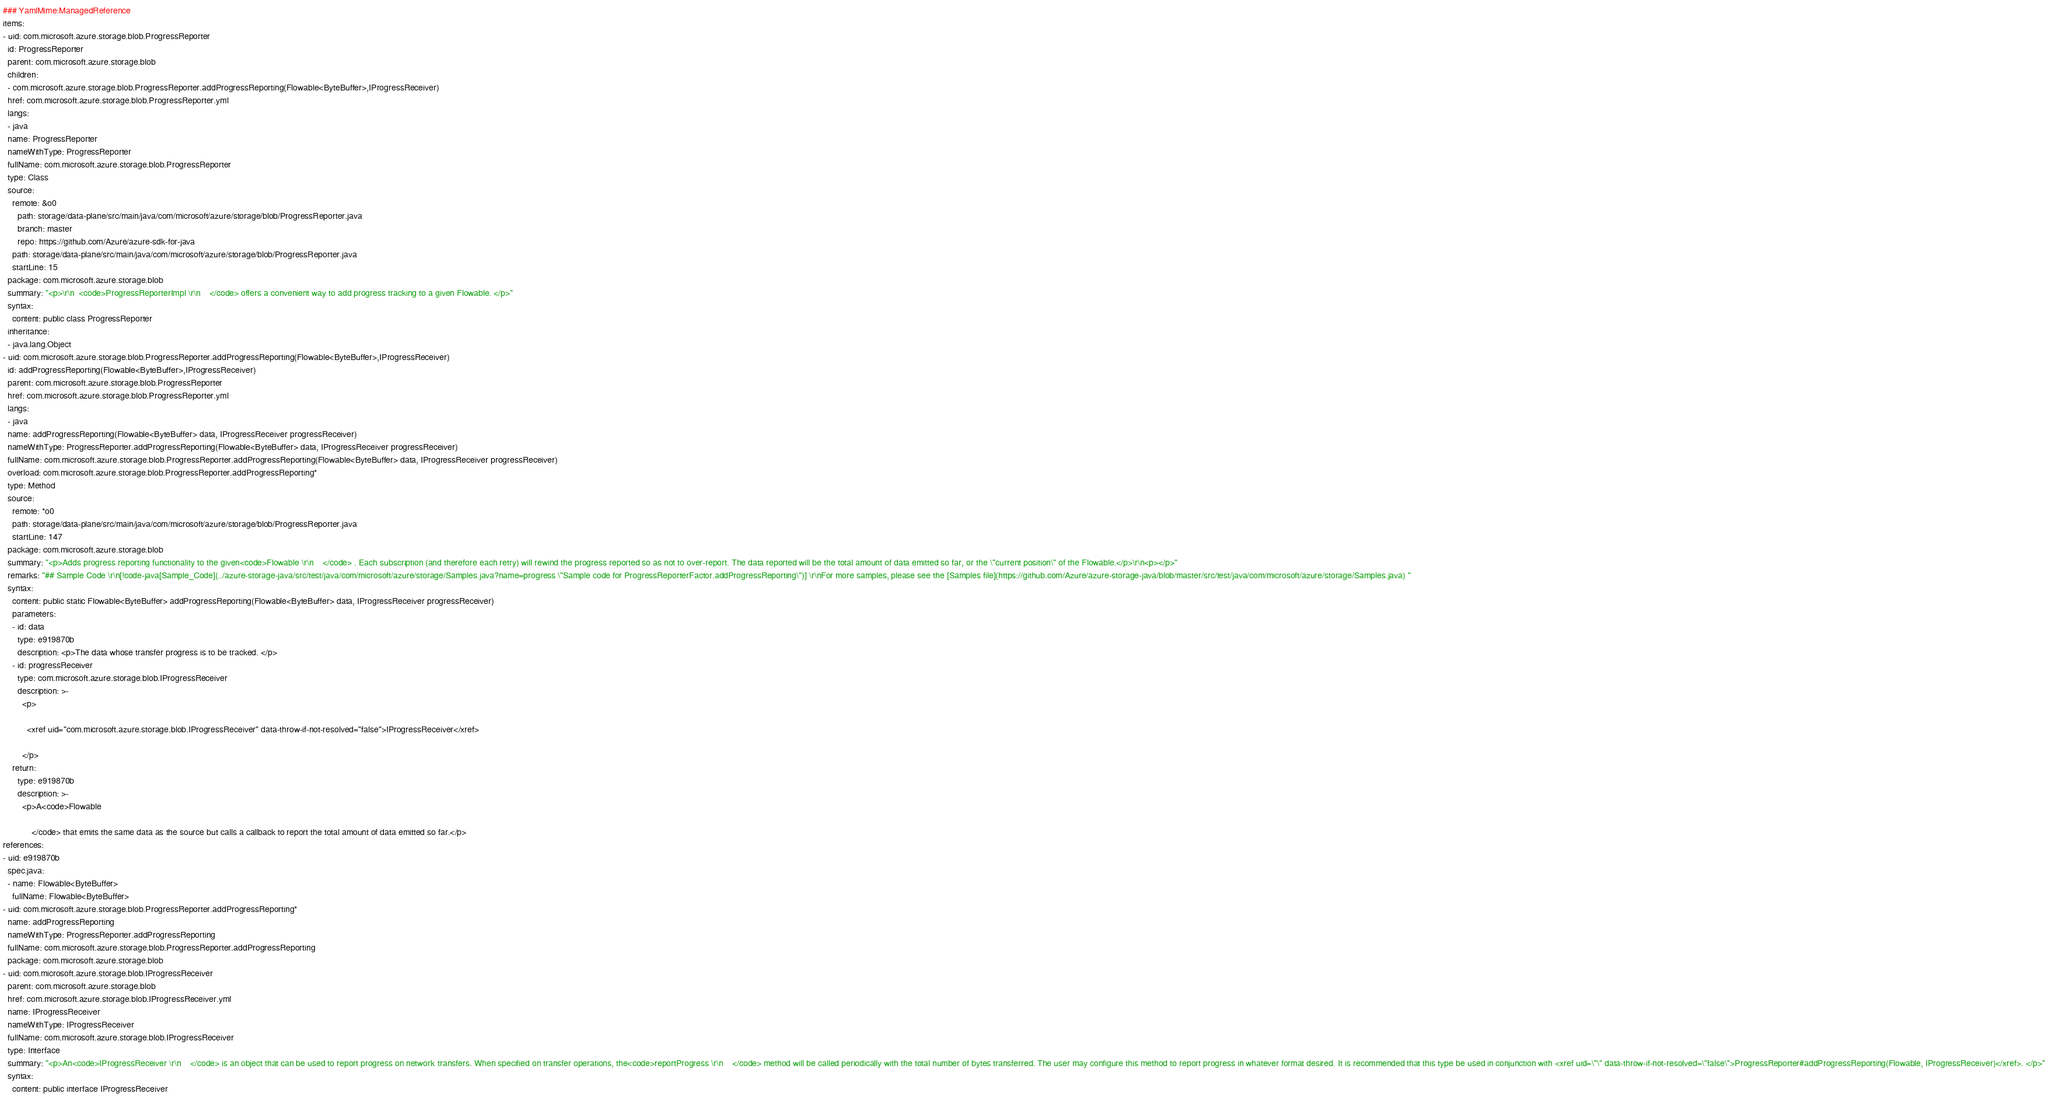Convert code to text. <code><loc_0><loc_0><loc_500><loc_500><_YAML_>### YamlMime:ManagedReference
items:
- uid: com.microsoft.azure.storage.blob.ProgressReporter
  id: ProgressReporter
  parent: com.microsoft.azure.storage.blob
  children:
  - com.microsoft.azure.storage.blob.ProgressReporter.addProgressReporting(Flowable<ByteBuffer>,IProgressReceiver)
  href: com.microsoft.azure.storage.blob.ProgressReporter.yml
  langs:
  - java
  name: ProgressReporter
  nameWithType: ProgressReporter
  fullName: com.microsoft.azure.storage.blob.ProgressReporter
  type: Class
  source:
    remote: &o0
      path: storage/data-plane/src/main/java/com/microsoft/azure/storage/blob/ProgressReporter.java
      branch: master
      repo: https://github.com/Azure/azure-sdk-for-java
    path: storage/data-plane/src/main/java/com/microsoft/azure/storage/blob/ProgressReporter.java
    startLine: 15
  package: com.microsoft.azure.storage.blob
  summary: "<p>\r\n  <code>ProgressReporterImpl \r\n    </code> offers a convenient way to add progress tracking to a given Flowable. </p>"
  syntax:
    content: public class ProgressReporter
  inheritance:
  - java.lang.Object
- uid: com.microsoft.azure.storage.blob.ProgressReporter.addProgressReporting(Flowable<ByteBuffer>,IProgressReceiver)
  id: addProgressReporting(Flowable<ByteBuffer>,IProgressReceiver)
  parent: com.microsoft.azure.storage.blob.ProgressReporter
  href: com.microsoft.azure.storage.blob.ProgressReporter.yml
  langs:
  - java
  name: addProgressReporting(Flowable<ByteBuffer> data, IProgressReceiver progressReceiver)
  nameWithType: ProgressReporter.addProgressReporting(Flowable<ByteBuffer> data, IProgressReceiver progressReceiver)
  fullName: com.microsoft.azure.storage.blob.ProgressReporter.addProgressReporting(Flowable<ByteBuffer> data, IProgressReceiver progressReceiver)
  overload: com.microsoft.azure.storage.blob.ProgressReporter.addProgressReporting*
  type: Method
  source:
    remote: *o0
    path: storage/data-plane/src/main/java/com/microsoft/azure/storage/blob/ProgressReporter.java
    startLine: 147
  package: com.microsoft.azure.storage.blob
  summary: "<p>Adds progress reporting functionality to the given<code>Flowable \r\n    </code> . Each subscription (and therefore each retry) will rewind the progress reported so as not to over-report. The data reported will be the total amount of data emitted so far, or the \"current position\" of the Flowable.</p>\r\n<p></p>"
  remarks: "## Sample Code \r\n[!code-java[Sample_Code](../azure-storage-java/src/test/java/com/microsoft/azure/storage/Samples.java?name=progress \"Sample code for ProgressReporterFactor.addProgressReporting\")] \r\nFor more samples, please see the [Samples file](https://github.com/Azure/azure-storage-java/blob/master/src/test/java/com/microsoft/azure/storage/Samples.java) "
  syntax:
    content: public static Flowable<ByteBuffer> addProgressReporting(Flowable<ByteBuffer> data, IProgressReceiver progressReceiver)
    parameters:
    - id: data
      type: e919870b
      description: <p>The data whose transfer progress is to be tracked. </p>
    - id: progressReceiver
      type: com.microsoft.azure.storage.blob.IProgressReceiver
      description: >-
        <p>

          <xref uid="com.microsoft.azure.storage.blob.IProgressReceiver" data-throw-if-not-resolved="false">IProgressReceiver</xref>

        </p>
    return:
      type: e919870b
      description: >-
        <p>A<code>Flowable 

            </code> that emits the same data as the source but calls a callback to report the total amount of data emitted so far.</p>
references:
- uid: e919870b
  spec.java:
  - name: Flowable<ByteBuffer>
    fullName: Flowable<ByteBuffer>
- uid: com.microsoft.azure.storage.blob.ProgressReporter.addProgressReporting*
  name: addProgressReporting
  nameWithType: ProgressReporter.addProgressReporting
  fullName: com.microsoft.azure.storage.blob.ProgressReporter.addProgressReporting
  package: com.microsoft.azure.storage.blob
- uid: com.microsoft.azure.storage.blob.IProgressReceiver
  parent: com.microsoft.azure.storage.blob
  href: com.microsoft.azure.storage.blob.IProgressReceiver.yml
  name: IProgressReceiver
  nameWithType: IProgressReceiver
  fullName: com.microsoft.azure.storage.blob.IProgressReceiver
  type: Interface
  summary: "<p>An<code>IProgressReceiver \r\n    </code> is an object that can be used to report progress on network transfers. When specified on transfer operations, the<code>reportProgress \r\n    </code> method will be called periodically with the total number of bytes transferred. The user may configure this method to report progress in whatever format desired. It is recommended that this type be used in conjunction with <xref uid=\"\" data-throw-if-not-resolved=\"false\">ProgressReporter#addProgressReporting(Flowable, IProgressReceiver)</xref>. </p>"
  syntax:
    content: public interface IProgressReceiver
</code> 